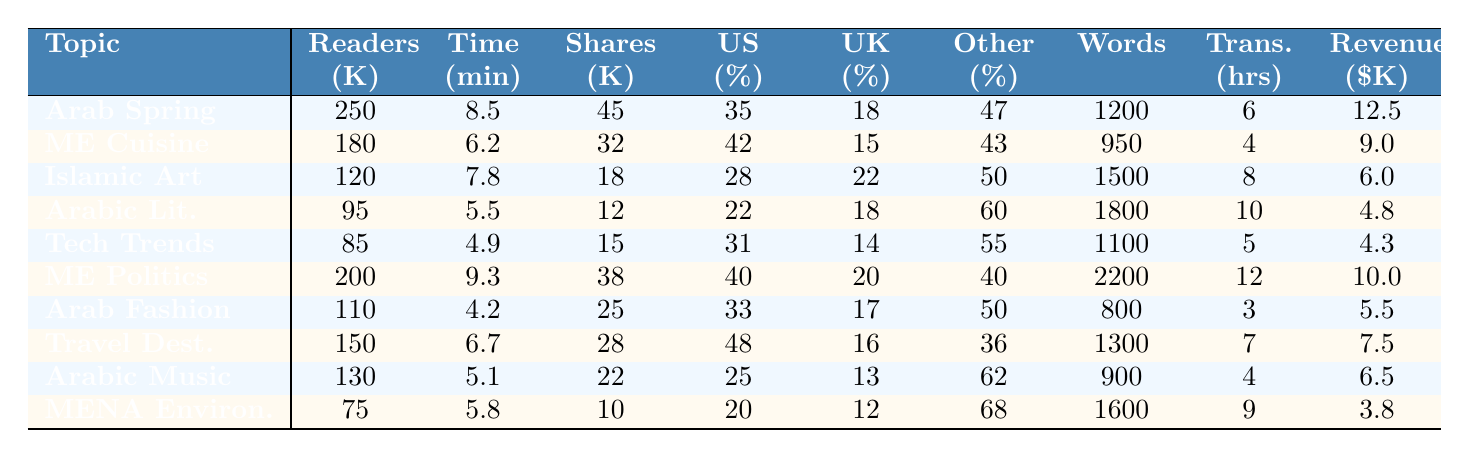What's the blog topic with the highest number of monthly English readers? The table indicates that "Arab Spring Updates" has the highest number of monthly English readers at 250,000.
Answer: Arab Spring Updates What is the average time spent by readers on the "Middle Eastern Cuisine" topic? The table shows that readers spend an average of 6.2 minutes on "Middle Eastern Cuisine".
Answer: 6.2 minutes Which blog topic has the lowest social media shares? According to the table, "MENA Environmental Issues" has the lowest social media shares at 10,000 shares.
Answer: MENA Environmental Issues What is the percentage of US readers for the blog topic "Arabic Literature Reviews"? The table reveals that "Arabic Literature Reviews" has 22% US readers.
Answer: 22% How many more monthly English readers does "Technology Trends in the Arab World" have compared to "Arabic Music and Entertainment"? "Technology Trends in the Arab World" has 85,000 readers, while "Arabic Music and Entertainment" has 130,000 readers. Thus, 130,000 - 85,000 = 45,000 more readers.
Answer: 45,000 more readers What is the average percentage of UK readers across all blog topics? To calculate the average percentage of UK readers, we sum the UK percentages (18 + 15 + 22 + 18 + 14 + 20 + 17 + 16 + 13 + 12 =  15.5) and divide by 10, yielding an average of 15.5%.
Answer: 15.5% Is "Travel Destinations in Arab Countries" more popular with readers from other English-speaking countries compared to "Arab Fashion and Beauty"? "Travel Destinations in Arab Countries" has 36% readers from other English-speaking countries, while "Arab Fashion and Beauty" has 50%. So, it is not more popular.
Answer: No Which blog topic has the highest translation turnaround time, and how long is it? The table indicates that "Middle East Politics Analysis" has the highest translation turnaround time at 12 hours.
Answer: Middle East Politics Analysis; 12 hours What is the total monthly ad revenue from the top three blog topics? The monthly ad revenue for the top three topics is 12,500 + 9,000 + 6,000 = 27,500 USD.
Answer: 27,500 USD What is the correlation between average word count and monthly ad revenue for the blog topics? Analyzing the data suggests a weak correlation as there isn't a consistent increase or decrease between word count and revenue across the topics.
Answer: Weak correlation 